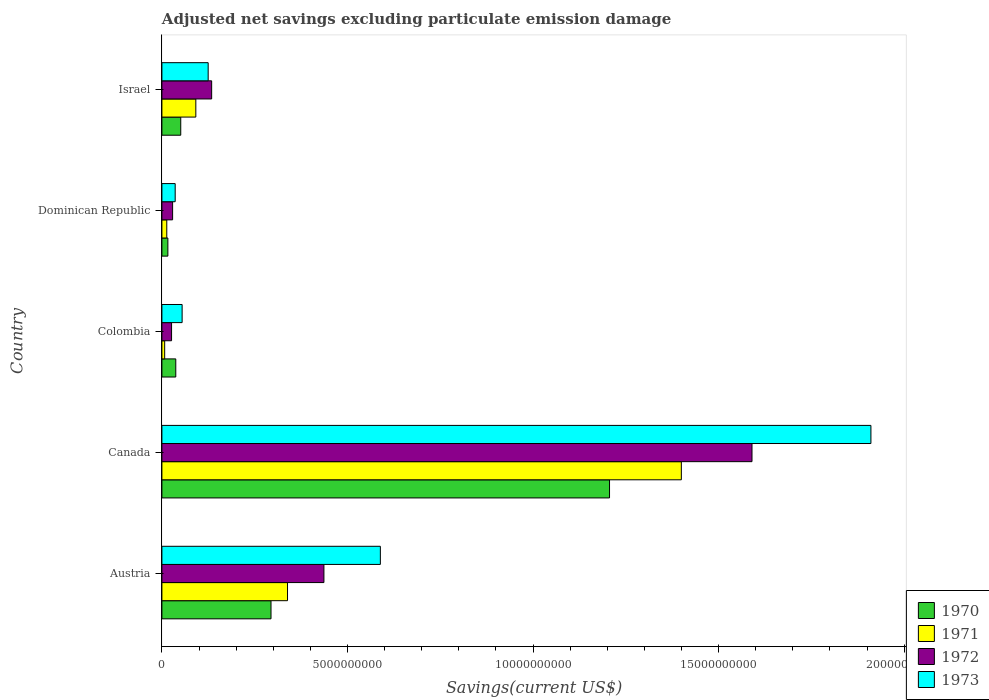How many groups of bars are there?
Offer a terse response. 5. Are the number of bars per tick equal to the number of legend labels?
Make the answer very short. Yes. How many bars are there on the 1st tick from the top?
Offer a terse response. 4. How many bars are there on the 2nd tick from the bottom?
Keep it short and to the point. 4. What is the label of the 3rd group of bars from the top?
Offer a terse response. Colombia. In how many cases, is the number of bars for a given country not equal to the number of legend labels?
Provide a succinct answer. 0. What is the adjusted net savings in 1972 in Canada?
Your answer should be compact. 1.59e+1. Across all countries, what is the maximum adjusted net savings in 1972?
Offer a terse response. 1.59e+1. Across all countries, what is the minimum adjusted net savings in 1970?
Your response must be concise. 1.61e+08. In which country was the adjusted net savings in 1971 maximum?
Offer a very short reply. Canada. In which country was the adjusted net savings in 1970 minimum?
Your answer should be very brief. Dominican Republic. What is the total adjusted net savings in 1971 in the graph?
Provide a succinct answer. 1.85e+1. What is the difference between the adjusted net savings in 1970 in Austria and that in Canada?
Ensure brevity in your answer.  -9.12e+09. What is the difference between the adjusted net savings in 1971 in Dominican Republic and the adjusted net savings in 1970 in Israel?
Provide a short and direct response. -3.76e+08. What is the average adjusted net savings in 1971 per country?
Offer a terse response. 3.70e+09. What is the difference between the adjusted net savings in 1971 and adjusted net savings in 1972 in Israel?
Make the answer very short. -4.27e+08. In how many countries, is the adjusted net savings in 1972 greater than 8000000000 US$?
Your answer should be very brief. 1. What is the ratio of the adjusted net savings in 1973 in Colombia to that in Dominican Republic?
Offer a very short reply. 1.52. Is the adjusted net savings in 1970 in Austria less than that in Dominican Republic?
Provide a short and direct response. No. What is the difference between the highest and the second highest adjusted net savings in 1972?
Your response must be concise. 1.15e+1. What is the difference between the highest and the lowest adjusted net savings in 1971?
Make the answer very short. 1.39e+1. In how many countries, is the adjusted net savings in 1972 greater than the average adjusted net savings in 1972 taken over all countries?
Keep it short and to the point. 1. Is the sum of the adjusted net savings in 1971 in Austria and Canada greater than the maximum adjusted net savings in 1973 across all countries?
Give a very brief answer. No. What does the 4th bar from the bottom in Israel represents?
Your response must be concise. 1973. How many bars are there?
Your answer should be very brief. 20. Are the values on the major ticks of X-axis written in scientific E-notation?
Make the answer very short. No. Does the graph contain any zero values?
Give a very brief answer. No. How are the legend labels stacked?
Keep it short and to the point. Vertical. What is the title of the graph?
Ensure brevity in your answer.  Adjusted net savings excluding particulate emission damage. Does "1977" appear as one of the legend labels in the graph?
Your response must be concise. No. What is the label or title of the X-axis?
Provide a short and direct response. Savings(current US$). What is the label or title of the Y-axis?
Give a very brief answer. Country. What is the Savings(current US$) of 1970 in Austria?
Your response must be concise. 2.94e+09. What is the Savings(current US$) of 1971 in Austria?
Ensure brevity in your answer.  3.38e+09. What is the Savings(current US$) in 1972 in Austria?
Your answer should be compact. 4.37e+09. What is the Savings(current US$) in 1973 in Austria?
Your response must be concise. 5.89e+09. What is the Savings(current US$) of 1970 in Canada?
Give a very brief answer. 1.21e+1. What is the Savings(current US$) in 1971 in Canada?
Provide a short and direct response. 1.40e+1. What is the Savings(current US$) of 1972 in Canada?
Ensure brevity in your answer.  1.59e+1. What is the Savings(current US$) of 1973 in Canada?
Your response must be concise. 1.91e+1. What is the Savings(current US$) of 1970 in Colombia?
Make the answer very short. 3.74e+08. What is the Savings(current US$) in 1971 in Colombia?
Keep it short and to the point. 7.46e+07. What is the Savings(current US$) of 1972 in Colombia?
Keep it short and to the point. 2.60e+08. What is the Savings(current US$) in 1973 in Colombia?
Provide a succinct answer. 5.45e+08. What is the Savings(current US$) in 1970 in Dominican Republic?
Ensure brevity in your answer.  1.61e+08. What is the Savings(current US$) of 1971 in Dominican Republic?
Make the answer very short. 1.32e+08. What is the Savings(current US$) of 1972 in Dominican Republic?
Your response must be concise. 2.89e+08. What is the Savings(current US$) in 1973 in Dominican Republic?
Offer a terse response. 3.58e+08. What is the Savings(current US$) of 1970 in Israel?
Keep it short and to the point. 5.08e+08. What is the Savings(current US$) in 1971 in Israel?
Make the answer very short. 9.14e+08. What is the Savings(current US$) in 1972 in Israel?
Offer a very short reply. 1.34e+09. What is the Savings(current US$) in 1973 in Israel?
Give a very brief answer. 1.25e+09. Across all countries, what is the maximum Savings(current US$) in 1970?
Give a very brief answer. 1.21e+1. Across all countries, what is the maximum Savings(current US$) in 1971?
Give a very brief answer. 1.40e+1. Across all countries, what is the maximum Savings(current US$) of 1972?
Keep it short and to the point. 1.59e+1. Across all countries, what is the maximum Savings(current US$) in 1973?
Your answer should be very brief. 1.91e+1. Across all countries, what is the minimum Savings(current US$) in 1970?
Provide a short and direct response. 1.61e+08. Across all countries, what is the minimum Savings(current US$) in 1971?
Give a very brief answer. 7.46e+07. Across all countries, what is the minimum Savings(current US$) of 1972?
Your response must be concise. 2.60e+08. Across all countries, what is the minimum Savings(current US$) in 1973?
Keep it short and to the point. 3.58e+08. What is the total Savings(current US$) in 1970 in the graph?
Your answer should be compact. 1.60e+1. What is the total Savings(current US$) in 1971 in the graph?
Keep it short and to the point. 1.85e+1. What is the total Savings(current US$) of 1972 in the graph?
Your response must be concise. 2.22e+1. What is the total Savings(current US$) in 1973 in the graph?
Provide a short and direct response. 2.71e+1. What is the difference between the Savings(current US$) of 1970 in Austria and that in Canada?
Offer a terse response. -9.12e+09. What is the difference between the Savings(current US$) in 1971 in Austria and that in Canada?
Offer a terse response. -1.06e+1. What is the difference between the Savings(current US$) in 1972 in Austria and that in Canada?
Ensure brevity in your answer.  -1.15e+1. What is the difference between the Savings(current US$) in 1973 in Austria and that in Canada?
Provide a short and direct response. -1.32e+1. What is the difference between the Savings(current US$) of 1970 in Austria and that in Colombia?
Provide a short and direct response. 2.57e+09. What is the difference between the Savings(current US$) of 1971 in Austria and that in Colombia?
Give a very brief answer. 3.31e+09. What is the difference between the Savings(current US$) in 1972 in Austria and that in Colombia?
Keep it short and to the point. 4.11e+09. What is the difference between the Savings(current US$) of 1973 in Austria and that in Colombia?
Offer a terse response. 5.34e+09. What is the difference between the Savings(current US$) in 1970 in Austria and that in Dominican Republic?
Make the answer very short. 2.78e+09. What is the difference between the Savings(current US$) in 1971 in Austria and that in Dominican Republic?
Your answer should be compact. 3.25e+09. What is the difference between the Savings(current US$) in 1972 in Austria and that in Dominican Republic?
Ensure brevity in your answer.  4.08e+09. What is the difference between the Savings(current US$) of 1973 in Austria and that in Dominican Republic?
Offer a very short reply. 5.53e+09. What is the difference between the Savings(current US$) of 1970 in Austria and that in Israel?
Your response must be concise. 2.43e+09. What is the difference between the Savings(current US$) in 1971 in Austria and that in Israel?
Give a very brief answer. 2.47e+09. What is the difference between the Savings(current US$) in 1972 in Austria and that in Israel?
Your answer should be compact. 3.02e+09. What is the difference between the Savings(current US$) in 1973 in Austria and that in Israel?
Provide a succinct answer. 4.64e+09. What is the difference between the Savings(current US$) of 1970 in Canada and that in Colombia?
Offer a terse response. 1.17e+1. What is the difference between the Savings(current US$) in 1971 in Canada and that in Colombia?
Offer a very short reply. 1.39e+1. What is the difference between the Savings(current US$) in 1972 in Canada and that in Colombia?
Your response must be concise. 1.56e+1. What is the difference between the Savings(current US$) in 1973 in Canada and that in Colombia?
Give a very brief answer. 1.86e+1. What is the difference between the Savings(current US$) of 1970 in Canada and that in Dominican Republic?
Offer a terse response. 1.19e+1. What is the difference between the Savings(current US$) of 1971 in Canada and that in Dominican Republic?
Keep it short and to the point. 1.39e+1. What is the difference between the Savings(current US$) in 1972 in Canada and that in Dominican Republic?
Ensure brevity in your answer.  1.56e+1. What is the difference between the Savings(current US$) in 1973 in Canada and that in Dominican Republic?
Your answer should be very brief. 1.87e+1. What is the difference between the Savings(current US$) in 1970 in Canada and that in Israel?
Your answer should be very brief. 1.16e+1. What is the difference between the Savings(current US$) of 1971 in Canada and that in Israel?
Offer a very short reply. 1.31e+1. What is the difference between the Savings(current US$) in 1972 in Canada and that in Israel?
Your answer should be compact. 1.46e+1. What is the difference between the Savings(current US$) of 1973 in Canada and that in Israel?
Provide a succinct answer. 1.79e+1. What is the difference between the Savings(current US$) of 1970 in Colombia and that in Dominican Republic?
Ensure brevity in your answer.  2.13e+08. What is the difference between the Savings(current US$) in 1971 in Colombia and that in Dominican Republic?
Give a very brief answer. -5.69e+07. What is the difference between the Savings(current US$) in 1972 in Colombia and that in Dominican Republic?
Provide a succinct answer. -2.84e+07. What is the difference between the Savings(current US$) in 1973 in Colombia and that in Dominican Republic?
Offer a terse response. 1.87e+08. What is the difference between the Savings(current US$) in 1970 in Colombia and that in Israel?
Offer a very short reply. -1.34e+08. What is the difference between the Savings(current US$) of 1971 in Colombia and that in Israel?
Offer a terse response. -8.40e+08. What is the difference between the Savings(current US$) in 1972 in Colombia and that in Israel?
Give a very brief answer. -1.08e+09. What is the difference between the Savings(current US$) in 1973 in Colombia and that in Israel?
Ensure brevity in your answer.  -7.02e+08. What is the difference between the Savings(current US$) of 1970 in Dominican Republic and that in Israel?
Provide a short and direct response. -3.47e+08. What is the difference between the Savings(current US$) of 1971 in Dominican Republic and that in Israel?
Provide a short and direct response. -7.83e+08. What is the difference between the Savings(current US$) in 1972 in Dominican Republic and that in Israel?
Provide a succinct answer. -1.05e+09. What is the difference between the Savings(current US$) in 1973 in Dominican Republic and that in Israel?
Your response must be concise. -8.89e+08. What is the difference between the Savings(current US$) of 1970 in Austria and the Savings(current US$) of 1971 in Canada?
Offer a terse response. -1.11e+1. What is the difference between the Savings(current US$) of 1970 in Austria and the Savings(current US$) of 1972 in Canada?
Provide a short and direct response. -1.30e+1. What is the difference between the Savings(current US$) of 1970 in Austria and the Savings(current US$) of 1973 in Canada?
Provide a short and direct response. -1.62e+1. What is the difference between the Savings(current US$) in 1971 in Austria and the Savings(current US$) in 1972 in Canada?
Your response must be concise. -1.25e+1. What is the difference between the Savings(current US$) of 1971 in Austria and the Savings(current US$) of 1973 in Canada?
Make the answer very short. -1.57e+1. What is the difference between the Savings(current US$) in 1972 in Austria and the Savings(current US$) in 1973 in Canada?
Offer a terse response. -1.47e+1. What is the difference between the Savings(current US$) in 1970 in Austria and the Savings(current US$) in 1971 in Colombia?
Your answer should be very brief. 2.87e+09. What is the difference between the Savings(current US$) of 1970 in Austria and the Savings(current US$) of 1972 in Colombia?
Provide a succinct answer. 2.68e+09. What is the difference between the Savings(current US$) of 1970 in Austria and the Savings(current US$) of 1973 in Colombia?
Offer a very short reply. 2.40e+09. What is the difference between the Savings(current US$) in 1971 in Austria and the Savings(current US$) in 1972 in Colombia?
Ensure brevity in your answer.  3.12e+09. What is the difference between the Savings(current US$) in 1971 in Austria and the Savings(current US$) in 1973 in Colombia?
Your answer should be very brief. 2.84e+09. What is the difference between the Savings(current US$) of 1972 in Austria and the Savings(current US$) of 1973 in Colombia?
Offer a terse response. 3.82e+09. What is the difference between the Savings(current US$) in 1970 in Austria and the Savings(current US$) in 1971 in Dominican Republic?
Your response must be concise. 2.81e+09. What is the difference between the Savings(current US$) of 1970 in Austria and the Savings(current US$) of 1972 in Dominican Republic?
Make the answer very short. 2.65e+09. What is the difference between the Savings(current US$) in 1970 in Austria and the Savings(current US$) in 1973 in Dominican Republic?
Ensure brevity in your answer.  2.58e+09. What is the difference between the Savings(current US$) in 1971 in Austria and the Savings(current US$) in 1972 in Dominican Republic?
Ensure brevity in your answer.  3.10e+09. What is the difference between the Savings(current US$) in 1971 in Austria and the Savings(current US$) in 1973 in Dominican Republic?
Provide a succinct answer. 3.03e+09. What is the difference between the Savings(current US$) in 1972 in Austria and the Savings(current US$) in 1973 in Dominican Republic?
Your answer should be compact. 4.01e+09. What is the difference between the Savings(current US$) of 1970 in Austria and the Savings(current US$) of 1971 in Israel?
Provide a short and direct response. 2.03e+09. What is the difference between the Savings(current US$) of 1970 in Austria and the Savings(current US$) of 1972 in Israel?
Keep it short and to the point. 1.60e+09. What is the difference between the Savings(current US$) in 1970 in Austria and the Savings(current US$) in 1973 in Israel?
Ensure brevity in your answer.  1.69e+09. What is the difference between the Savings(current US$) in 1971 in Austria and the Savings(current US$) in 1972 in Israel?
Your answer should be very brief. 2.04e+09. What is the difference between the Savings(current US$) of 1971 in Austria and the Savings(current US$) of 1973 in Israel?
Keep it short and to the point. 2.14e+09. What is the difference between the Savings(current US$) of 1972 in Austria and the Savings(current US$) of 1973 in Israel?
Your response must be concise. 3.12e+09. What is the difference between the Savings(current US$) of 1970 in Canada and the Savings(current US$) of 1971 in Colombia?
Give a very brief answer. 1.20e+1. What is the difference between the Savings(current US$) of 1970 in Canada and the Savings(current US$) of 1972 in Colombia?
Provide a succinct answer. 1.18e+1. What is the difference between the Savings(current US$) of 1970 in Canada and the Savings(current US$) of 1973 in Colombia?
Provide a short and direct response. 1.15e+1. What is the difference between the Savings(current US$) of 1971 in Canada and the Savings(current US$) of 1972 in Colombia?
Ensure brevity in your answer.  1.37e+1. What is the difference between the Savings(current US$) in 1971 in Canada and the Savings(current US$) in 1973 in Colombia?
Provide a succinct answer. 1.35e+1. What is the difference between the Savings(current US$) in 1972 in Canada and the Savings(current US$) in 1973 in Colombia?
Offer a terse response. 1.54e+1. What is the difference between the Savings(current US$) of 1970 in Canada and the Savings(current US$) of 1971 in Dominican Republic?
Provide a succinct answer. 1.19e+1. What is the difference between the Savings(current US$) of 1970 in Canada and the Savings(current US$) of 1972 in Dominican Republic?
Provide a succinct answer. 1.18e+1. What is the difference between the Savings(current US$) of 1970 in Canada and the Savings(current US$) of 1973 in Dominican Republic?
Your response must be concise. 1.17e+1. What is the difference between the Savings(current US$) of 1971 in Canada and the Savings(current US$) of 1972 in Dominican Republic?
Provide a succinct answer. 1.37e+1. What is the difference between the Savings(current US$) in 1971 in Canada and the Savings(current US$) in 1973 in Dominican Republic?
Keep it short and to the point. 1.36e+1. What is the difference between the Savings(current US$) of 1972 in Canada and the Savings(current US$) of 1973 in Dominican Republic?
Your answer should be very brief. 1.55e+1. What is the difference between the Savings(current US$) in 1970 in Canada and the Savings(current US$) in 1971 in Israel?
Provide a succinct answer. 1.11e+1. What is the difference between the Savings(current US$) of 1970 in Canada and the Savings(current US$) of 1972 in Israel?
Make the answer very short. 1.07e+1. What is the difference between the Savings(current US$) of 1970 in Canada and the Savings(current US$) of 1973 in Israel?
Ensure brevity in your answer.  1.08e+1. What is the difference between the Savings(current US$) in 1971 in Canada and the Savings(current US$) in 1972 in Israel?
Give a very brief answer. 1.27e+1. What is the difference between the Savings(current US$) of 1971 in Canada and the Savings(current US$) of 1973 in Israel?
Your response must be concise. 1.27e+1. What is the difference between the Savings(current US$) in 1972 in Canada and the Savings(current US$) in 1973 in Israel?
Offer a terse response. 1.47e+1. What is the difference between the Savings(current US$) in 1970 in Colombia and the Savings(current US$) in 1971 in Dominican Republic?
Keep it short and to the point. 2.42e+08. What is the difference between the Savings(current US$) in 1970 in Colombia and the Savings(current US$) in 1972 in Dominican Republic?
Offer a very short reply. 8.52e+07. What is the difference between the Savings(current US$) of 1970 in Colombia and the Savings(current US$) of 1973 in Dominican Republic?
Ensure brevity in your answer.  1.57e+07. What is the difference between the Savings(current US$) in 1971 in Colombia and the Savings(current US$) in 1972 in Dominican Republic?
Make the answer very short. -2.14e+08. What is the difference between the Savings(current US$) in 1971 in Colombia and the Savings(current US$) in 1973 in Dominican Republic?
Ensure brevity in your answer.  -2.84e+08. What is the difference between the Savings(current US$) of 1972 in Colombia and the Savings(current US$) of 1973 in Dominican Republic?
Keep it short and to the point. -9.79e+07. What is the difference between the Savings(current US$) of 1970 in Colombia and the Savings(current US$) of 1971 in Israel?
Offer a very short reply. -5.40e+08. What is the difference between the Savings(current US$) of 1970 in Colombia and the Savings(current US$) of 1972 in Israel?
Keep it short and to the point. -9.67e+08. What is the difference between the Savings(current US$) in 1970 in Colombia and the Savings(current US$) in 1973 in Israel?
Make the answer very short. -8.73e+08. What is the difference between the Savings(current US$) in 1971 in Colombia and the Savings(current US$) in 1972 in Israel?
Provide a succinct answer. -1.27e+09. What is the difference between the Savings(current US$) in 1971 in Colombia and the Savings(current US$) in 1973 in Israel?
Your answer should be very brief. -1.17e+09. What is the difference between the Savings(current US$) of 1972 in Colombia and the Savings(current US$) of 1973 in Israel?
Your answer should be very brief. -9.87e+08. What is the difference between the Savings(current US$) in 1970 in Dominican Republic and the Savings(current US$) in 1971 in Israel?
Give a very brief answer. -7.53e+08. What is the difference between the Savings(current US$) of 1970 in Dominican Republic and the Savings(current US$) of 1972 in Israel?
Your response must be concise. -1.18e+09. What is the difference between the Savings(current US$) of 1970 in Dominican Republic and the Savings(current US$) of 1973 in Israel?
Keep it short and to the point. -1.09e+09. What is the difference between the Savings(current US$) in 1971 in Dominican Republic and the Savings(current US$) in 1972 in Israel?
Your answer should be very brief. -1.21e+09. What is the difference between the Savings(current US$) of 1971 in Dominican Republic and the Savings(current US$) of 1973 in Israel?
Make the answer very short. -1.12e+09. What is the difference between the Savings(current US$) of 1972 in Dominican Republic and the Savings(current US$) of 1973 in Israel?
Provide a succinct answer. -9.58e+08. What is the average Savings(current US$) in 1970 per country?
Provide a succinct answer. 3.21e+09. What is the average Savings(current US$) in 1971 per country?
Give a very brief answer. 3.70e+09. What is the average Savings(current US$) in 1972 per country?
Ensure brevity in your answer.  4.43e+09. What is the average Savings(current US$) in 1973 per country?
Offer a very short reply. 5.43e+09. What is the difference between the Savings(current US$) of 1970 and Savings(current US$) of 1971 in Austria?
Keep it short and to the point. -4.45e+08. What is the difference between the Savings(current US$) in 1970 and Savings(current US$) in 1972 in Austria?
Offer a terse response. -1.43e+09. What is the difference between the Savings(current US$) in 1970 and Savings(current US$) in 1973 in Austria?
Keep it short and to the point. -2.95e+09. What is the difference between the Savings(current US$) in 1971 and Savings(current US$) in 1972 in Austria?
Your answer should be compact. -9.81e+08. What is the difference between the Savings(current US$) in 1971 and Savings(current US$) in 1973 in Austria?
Ensure brevity in your answer.  -2.50e+09. What is the difference between the Savings(current US$) in 1972 and Savings(current US$) in 1973 in Austria?
Offer a very short reply. -1.52e+09. What is the difference between the Savings(current US$) of 1970 and Savings(current US$) of 1971 in Canada?
Offer a very short reply. -1.94e+09. What is the difference between the Savings(current US$) in 1970 and Savings(current US$) in 1972 in Canada?
Provide a short and direct response. -3.84e+09. What is the difference between the Savings(current US$) in 1970 and Savings(current US$) in 1973 in Canada?
Your answer should be compact. -7.04e+09. What is the difference between the Savings(current US$) in 1971 and Savings(current US$) in 1972 in Canada?
Your answer should be very brief. -1.90e+09. What is the difference between the Savings(current US$) in 1971 and Savings(current US$) in 1973 in Canada?
Make the answer very short. -5.11e+09. What is the difference between the Savings(current US$) of 1972 and Savings(current US$) of 1973 in Canada?
Make the answer very short. -3.20e+09. What is the difference between the Savings(current US$) in 1970 and Savings(current US$) in 1971 in Colombia?
Ensure brevity in your answer.  2.99e+08. What is the difference between the Savings(current US$) of 1970 and Savings(current US$) of 1972 in Colombia?
Your response must be concise. 1.14e+08. What is the difference between the Savings(current US$) of 1970 and Savings(current US$) of 1973 in Colombia?
Your answer should be compact. -1.71e+08. What is the difference between the Savings(current US$) in 1971 and Savings(current US$) in 1972 in Colombia?
Provide a short and direct response. -1.86e+08. What is the difference between the Savings(current US$) in 1971 and Savings(current US$) in 1973 in Colombia?
Provide a succinct answer. -4.70e+08. What is the difference between the Savings(current US$) of 1972 and Savings(current US$) of 1973 in Colombia?
Your answer should be very brief. -2.85e+08. What is the difference between the Savings(current US$) of 1970 and Savings(current US$) of 1971 in Dominican Republic?
Make the answer very short. 2.96e+07. What is the difference between the Savings(current US$) of 1970 and Savings(current US$) of 1972 in Dominican Republic?
Provide a succinct answer. -1.28e+08. What is the difference between the Savings(current US$) in 1970 and Savings(current US$) in 1973 in Dominican Republic?
Provide a short and direct response. -1.97e+08. What is the difference between the Savings(current US$) of 1971 and Savings(current US$) of 1972 in Dominican Republic?
Give a very brief answer. -1.57e+08. What is the difference between the Savings(current US$) of 1971 and Savings(current US$) of 1973 in Dominican Republic?
Offer a terse response. -2.27e+08. What is the difference between the Savings(current US$) in 1972 and Savings(current US$) in 1973 in Dominican Republic?
Offer a terse response. -6.95e+07. What is the difference between the Savings(current US$) in 1970 and Savings(current US$) in 1971 in Israel?
Your response must be concise. -4.06e+08. What is the difference between the Savings(current US$) in 1970 and Savings(current US$) in 1972 in Israel?
Give a very brief answer. -8.33e+08. What is the difference between the Savings(current US$) of 1970 and Savings(current US$) of 1973 in Israel?
Offer a terse response. -7.39e+08. What is the difference between the Savings(current US$) in 1971 and Savings(current US$) in 1972 in Israel?
Offer a very short reply. -4.27e+08. What is the difference between the Savings(current US$) in 1971 and Savings(current US$) in 1973 in Israel?
Your response must be concise. -3.33e+08. What is the difference between the Savings(current US$) of 1972 and Savings(current US$) of 1973 in Israel?
Make the answer very short. 9.40e+07. What is the ratio of the Savings(current US$) of 1970 in Austria to that in Canada?
Keep it short and to the point. 0.24. What is the ratio of the Savings(current US$) of 1971 in Austria to that in Canada?
Offer a very short reply. 0.24. What is the ratio of the Savings(current US$) in 1972 in Austria to that in Canada?
Your answer should be very brief. 0.27. What is the ratio of the Savings(current US$) in 1973 in Austria to that in Canada?
Your answer should be compact. 0.31. What is the ratio of the Savings(current US$) of 1970 in Austria to that in Colombia?
Provide a succinct answer. 7.86. What is the ratio of the Savings(current US$) of 1971 in Austria to that in Colombia?
Keep it short and to the point. 45.37. What is the ratio of the Savings(current US$) in 1972 in Austria to that in Colombia?
Keep it short and to the point. 16.77. What is the ratio of the Savings(current US$) of 1973 in Austria to that in Colombia?
Ensure brevity in your answer.  10.8. What is the ratio of the Savings(current US$) in 1970 in Austria to that in Dominican Republic?
Ensure brevity in your answer.  18.25. What is the ratio of the Savings(current US$) of 1971 in Austria to that in Dominican Republic?
Your answer should be very brief. 25.73. What is the ratio of the Savings(current US$) in 1972 in Austria to that in Dominican Republic?
Ensure brevity in your answer.  15.12. What is the ratio of the Savings(current US$) in 1973 in Austria to that in Dominican Republic?
Give a very brief answer. 16.43. What is the ratio of the Savings(current US$) of 1970 in Austria to that in Israel?
Offer a terse response. 5.79. What is the ratio of the Savings(current US$) of 1971 in Austria to that in Israel?
Your answer should be compact. 3.7. What is the ratio of the Savings(current US$) in 1972 in Austria to that in Israel?
Give a very brief answer. 3.26. What is the ratio of the Savings(current US$) in 1973 in Austria to that in Israel?
Provide a succinct answer. 4.72. What is the ratio of the Savings(current US$) in 1970 in Canada to that in Colombia?
Your answer should be compact. 32.26. What is the ratio of the Savings(current US$) of 1971 in Canada to that in Colombia?
Offer a very short reply. 187.59. What is the ratio of the Savings(current US$) in 1972 in Canada to that in Colombia?
Keep it short and to the point. 61.09. What is the ratio of the Savings(current US$) of 1973 in Canada to that in Colombia?
Your answer should be very brief. 35.07. What is the ratio of the Savings(current US$) in 1970 in Canada to that in Dominican Republic?
Provide a short and direct response. 74.87. What is the ratio of the Savings(current US$) in 1971 in Canada to that in Dominican Republic?
Ensure brevity in your answer.  106.4. What is the ratio of the Savings(current US$) in 1972 in Canada to that in Dominican Republic?
Your answer should be very brief. 55.08. What is the ratio of the Savings(current US$) in 1973 in Canada to that in Dominican Republic?
Keep it short and to the point. 53.33. What is the ratio of the Savings(current US$) in 1970 in Canada to that in Israel?
Provide a short and direct response. 23.75. What is the ratio of the Savings(current US$) in 1971 in Canada to that in Israel?
Your answer should be very brief. 15.31. What is the ratio of the Savings(current US$) of 1972 in Canada to that in Israel?
Keep it short and to the point. 11.86. What is the ratio of the Savings(current US$) in 1973 in Canada to that in Israel?
Make the answer very short. 15.32. What is the ratio of the Savings(current US$) in 1970 in Colombia to that in Dominican Republic?
Make the answer very short. 2.32. What is the ratio of the Savings(current US$) of 1971 in Colombia to that in Dominican Republic?
Your response must be concise. 0.57. What is the ratio of the Savings(current US$) of 1972 in Colombia to that in Dominican Republic?
Your answer should be compact. 0.9. What is the ratio of the Savings(current US$) of 1973 in Colombia to that in Dominican Republic?
Your answer should be compact. 1.52. What is the ratio of the Savings(current US$) of 1970 in Colombia to that in Israel?
Make the answer very short. 0.74. What is the ratio of the Savings(current US$) in 1971 in Colombia to that in Israel?
Your answer should be very brief. 0.08. What is the ratio of the Savings(current US$) in 1972 in Colombia to that in Israel?
Offer a very short reply. 0.19. What is the ratio of the Savings(current US$) of 1973 in Colombia to that in Israel?
Your answer should be very brief. 0.44. What is the ratio of the Savings(current US$) in 1970 in Dominican Republic to that in Israel?
Your answer should be very brief. 0.32. What is the ratio of the Savings(current US$) of 1971 in Dominican Republic to that in Israel?
Provide a short and direct response. 0.14. What is the ratio of the Savings(current US$) of 1972 in Dominican Republic to that in Israel?
Give a very brief answer. 0.22. What is the ratio of the Savings(current US$) in 1973 in Dominican Republic to that in Israel?
Provide a succinct answer. 0.29. What is the difference between the highest and the second highest Savings(current US$) in 1970?
Provide a succinct answer. 9.12e+09. What is the difference between the highest and the second highest Savings(current US$) in 1971?
Your answer should be compact. 1.06e+1. What is the difference between the highest and the second highest Savings(current US$) of 1972?
Offer a terse response. 1.15e+1. What is the difference between the highest and the second highest Savings(current US$) of 1973?
Your answer should be very brief. 1.32e+1. What is the difference between the highest and the lowest Savings(current US$) in 1970?
Offer a terse response. 1.19e+1. What is the difference between the highest and the lowest Savings(current US$) of 1971?
Your response must be concise. 1.39e+1. What is the difference between the highest and the lowest Savings(current US$) of 1972?
Make the answer very short. 1.56e+1. What is the difference between the highest and the lowest Savings(current US$) of 1973?
Your answer should be compact. 1.87e+1. 